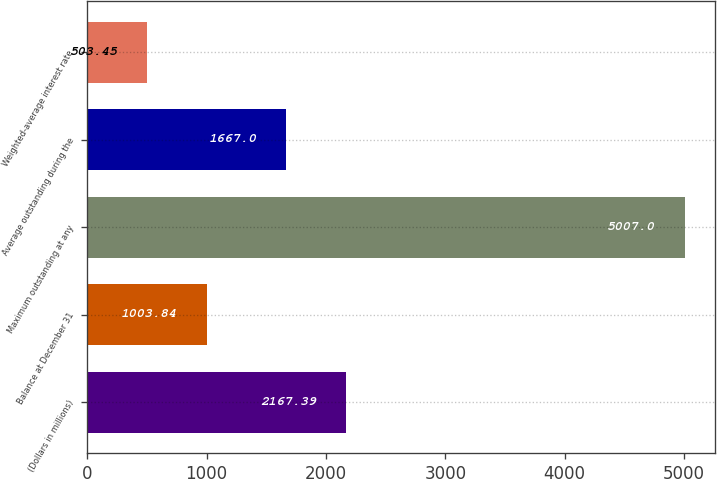Convert chart to OTSL. <chart><loc_0><loc_0><loc_500><loc_500><bar_chart><fcel>(Dollars in millions)<fcel>Balance at December 31<fcel>Maximum outstanding at any<fcel>Average outstanding during the<fcel>Weighted-average interest rate<nl><fcel>2167.39<fcel>1003.84<fcel>5007<fcel>1667<fcel>503.45<nl></chart> 